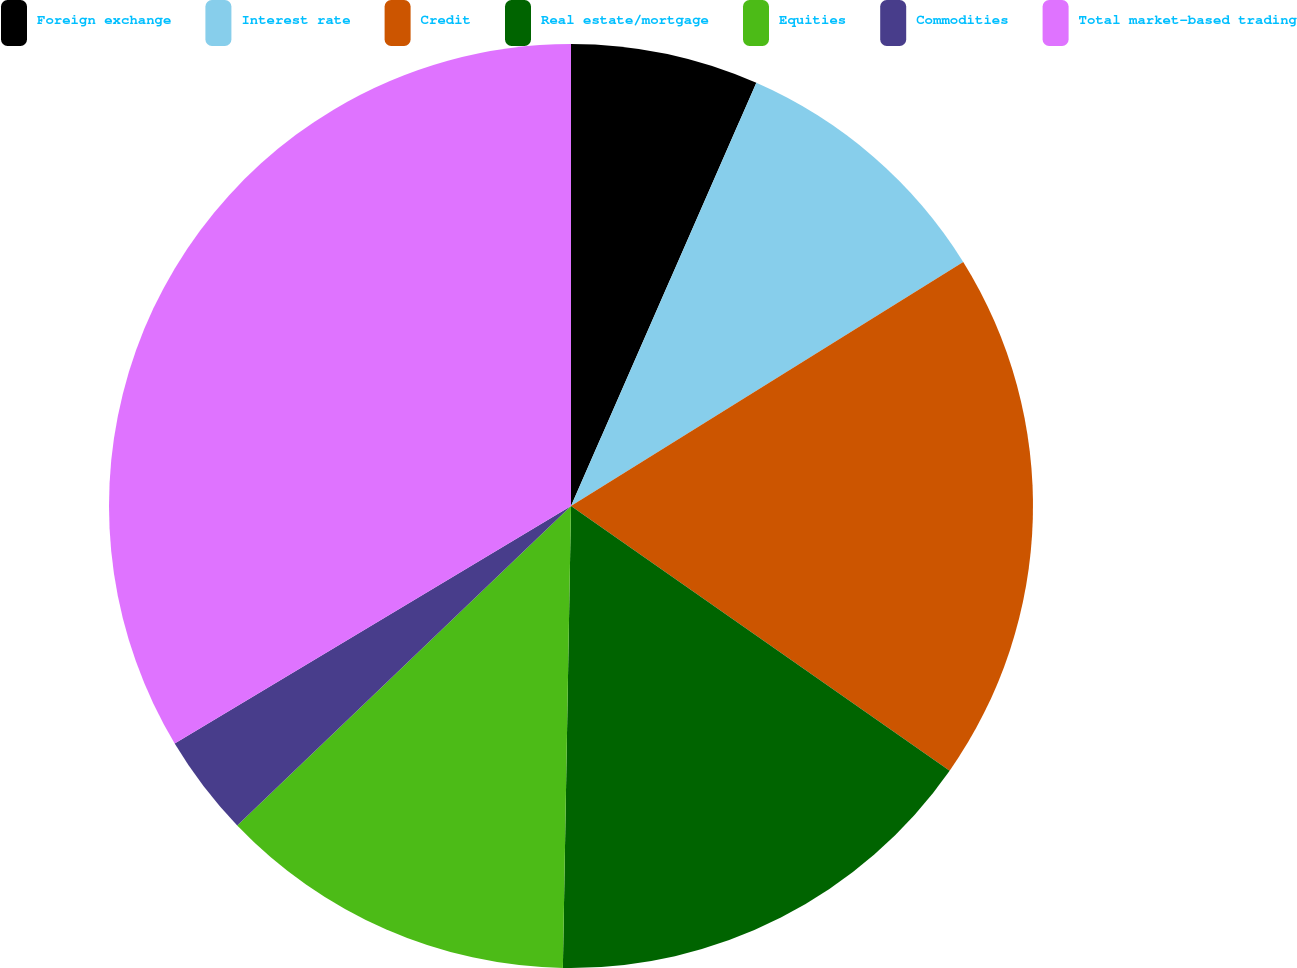Convert chart. <chart><loc_0><loc_0><loc_500><loc_500><pie_chart><fcel>Foreign exchange<fcel>Interest rate<fcel>Credit<fcel>Real estate/mortgage<fcel>Equities<fcel>Commodities<fcel>Total market-based trading<nl><fcel>6.57%<fcel>9.57%<fcel>18.57%<fcel>15.57%<fcel>12.57%<fcel>3.56%<fcel>33.59%<nl></chart> 